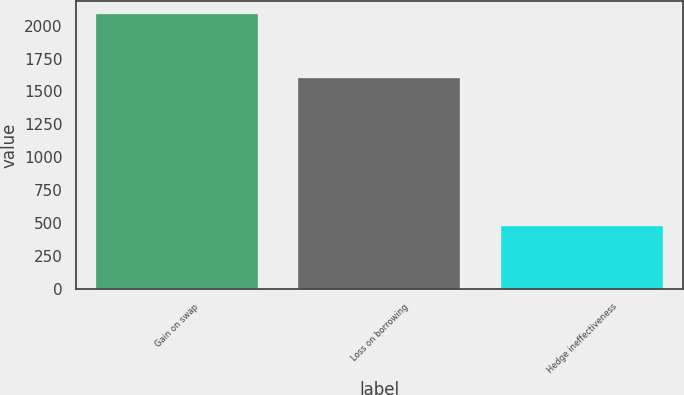<chart> <loc_0><loc_0><loc_500><loc_500><bar_chart><fcel>Gain on swap<fcel>Loss on borrowing<fcel>Hedge ineffectiveness<nl><fcel>2085<fcel>1604<fcel>481<nl></chart> 